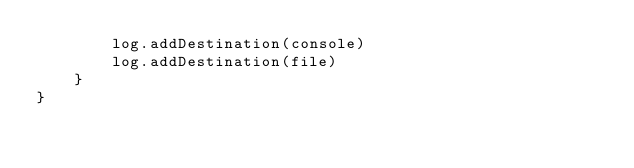Convert code to text. <code><loc_0><loc_0><loc_500><loc_500><_Swift_>        log.addDestination(console)
        log.addDestination(file)
    }
}
</code> 